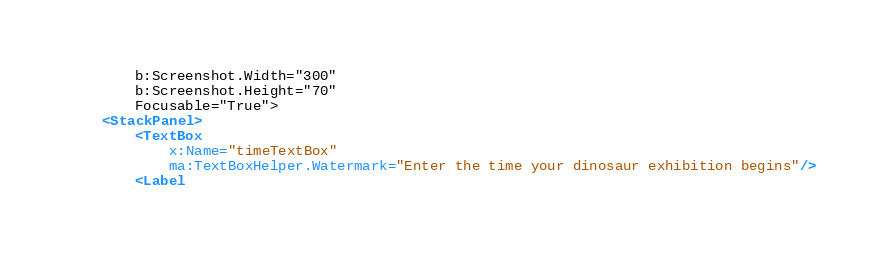<code> <loc_0><loc_0><loc_500><loc_500><_XML_>        b:Screenshot.Width="300"
        b:Screenshot.Height="70"
        Focusable="True">
    <StackPanel>
        <TextBox
            x:Name="timeTextBox"
            ma:TextBoxHelper.Watermark="Enter the time your dinosaur exhibition begins"/>
        <Label</code> 